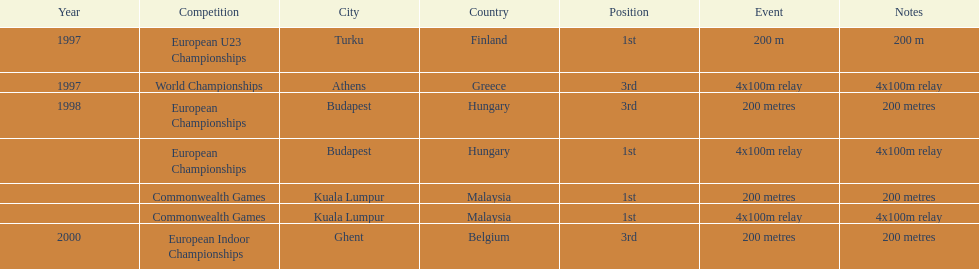How many events were won in malaysia? 2. 